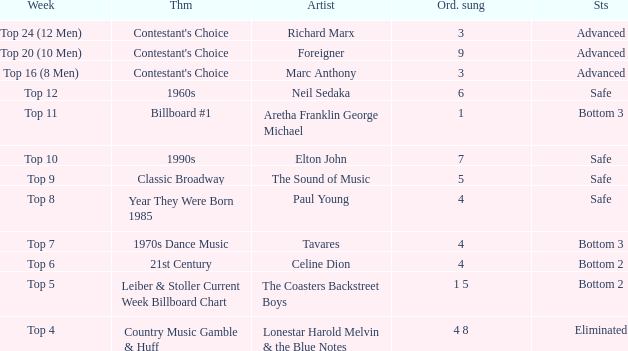What week did the contestant finish in the bottom 2 with a Celine Dion song? Top 6. 